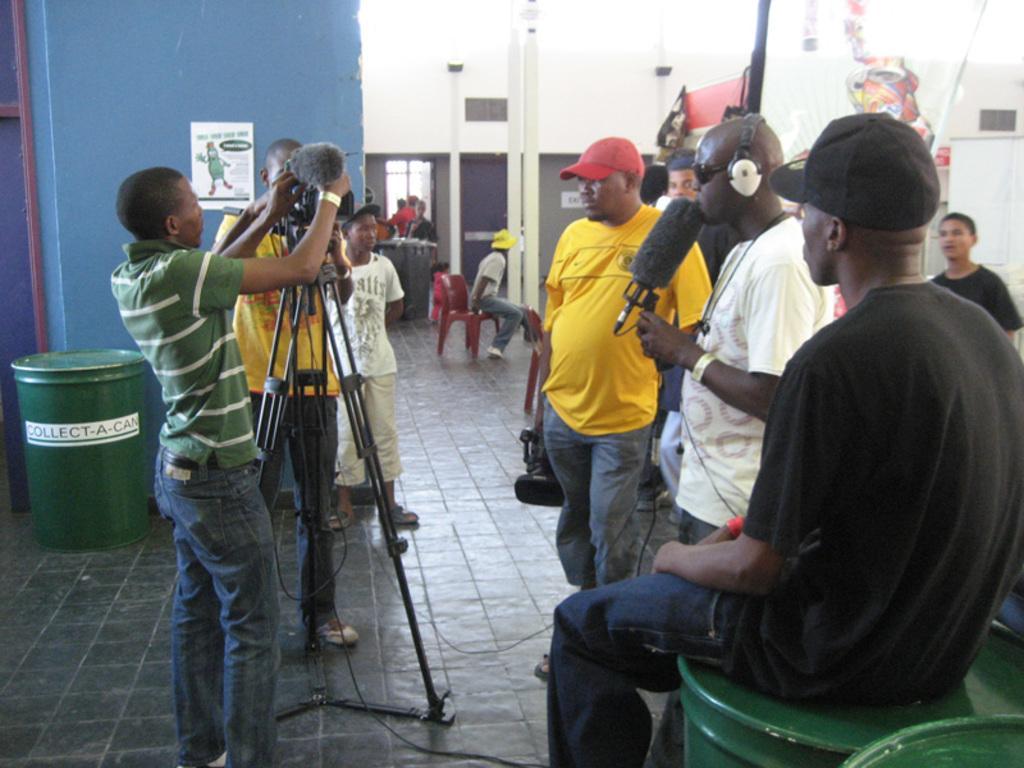Could you give a brief overview of what you see in this image? In the image we can see there are any people wearing clothes and some are wearing a cap. Two of them are sitting and the rest are standing, this is a banner, floor, video camera, stand, microphone, headsets, goggles and a window. We can even see there are chairs, red in color. 